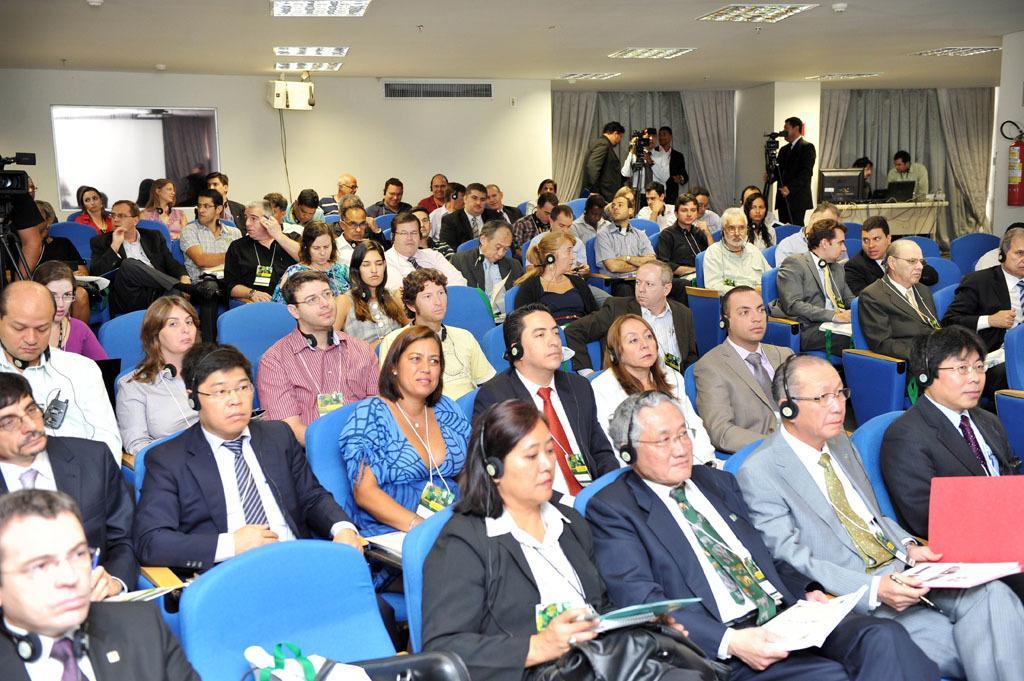Could you give a brief overview of what you see in this image? At the top we can see the ceiling and the lights. In the background we can see the curtains, wall and an object. In this picture we can see the people sitting on the chairs and among them few people wore headphones, few are holding files. On the right side of the picture we can see the people standing. We can see the cameras and the stands. We can see the men near to the table and on the table we can see a laptop and a monitor. We can see a fire extinguisher and the wall. On the left side of the picture we can see a person is standing, camera and a stand. 